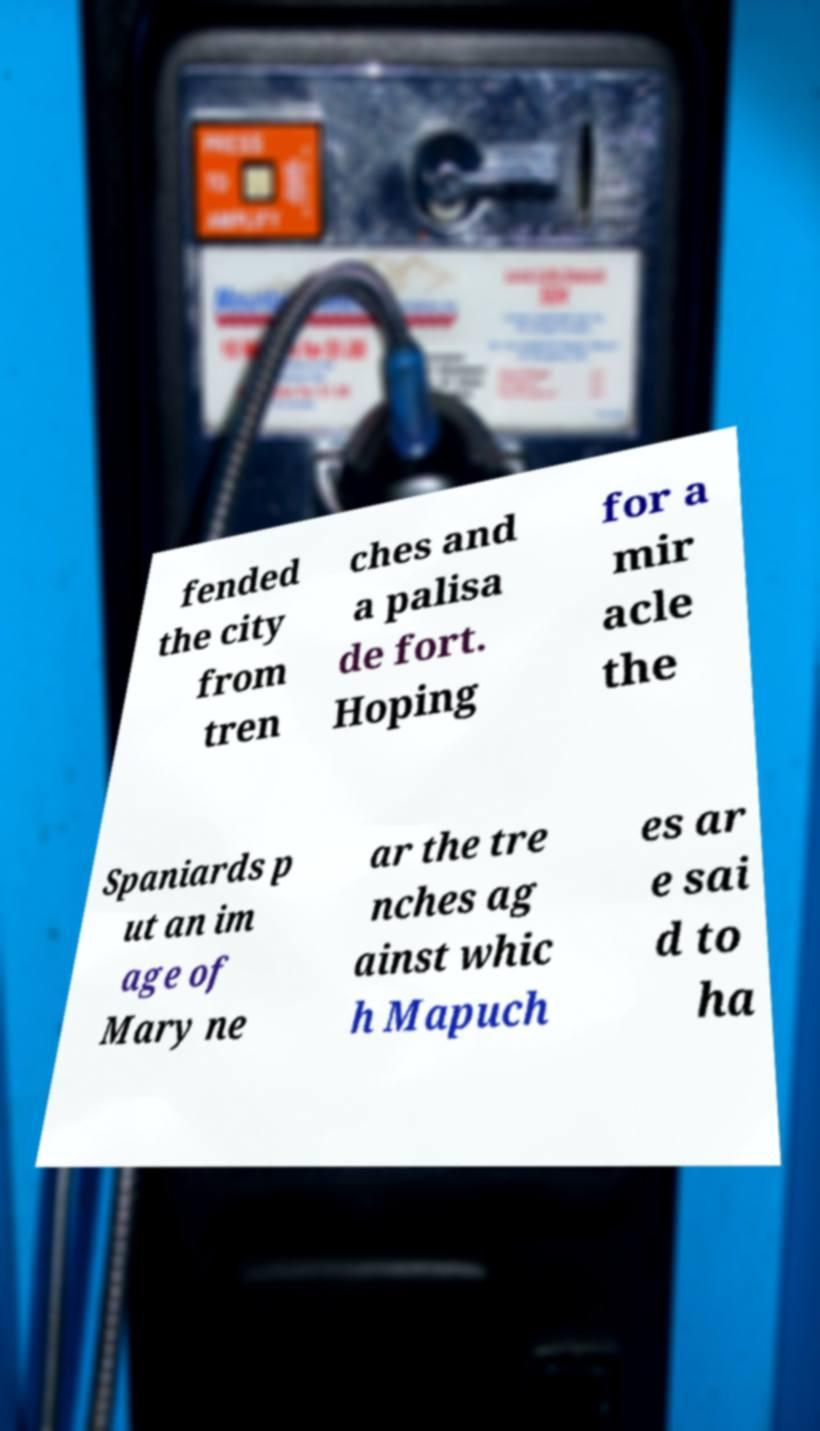Could you assist in decoding the text presented in this image and type it out clearly? fended the city from tren ches and a palisa de fort. Hoping for a mir acle the Spaniards p ut an im age of Mary ne ar the tre nches ag ainst whic h Mapuch es ar e sai d to ha 